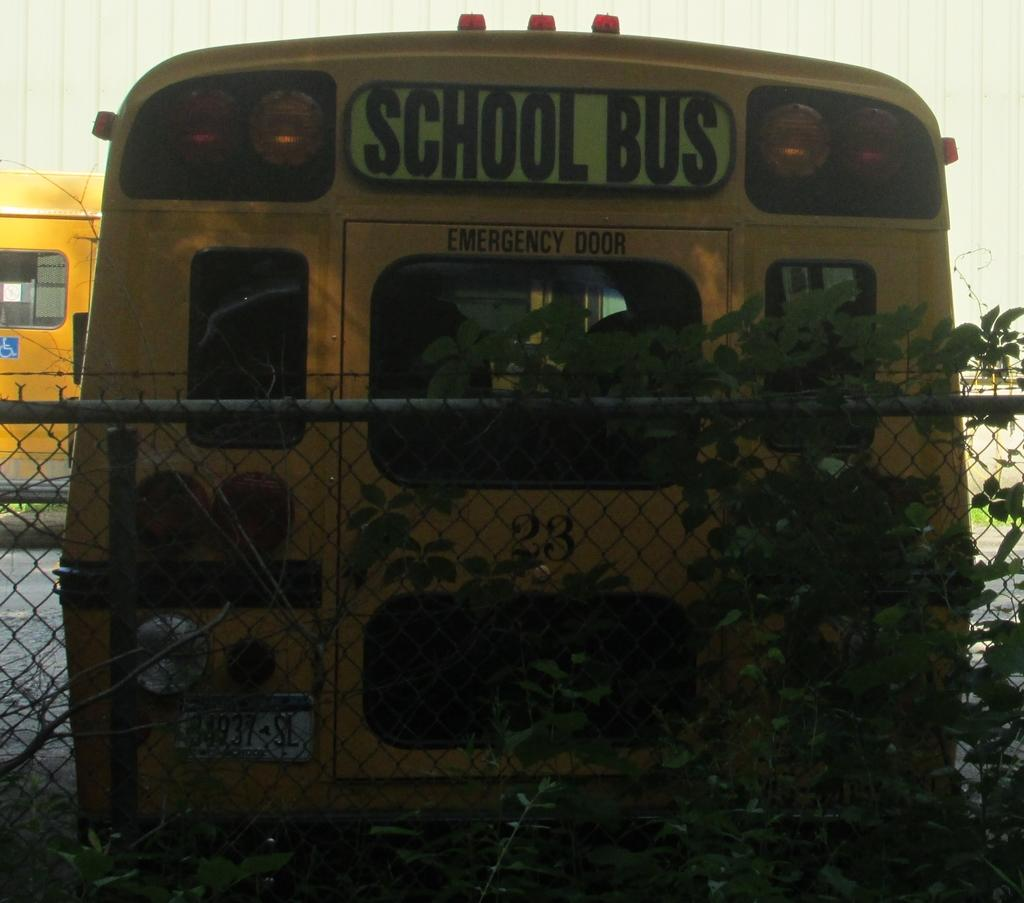<image>
Describe the image concisely. The school bus was parked next to a wired fence. 